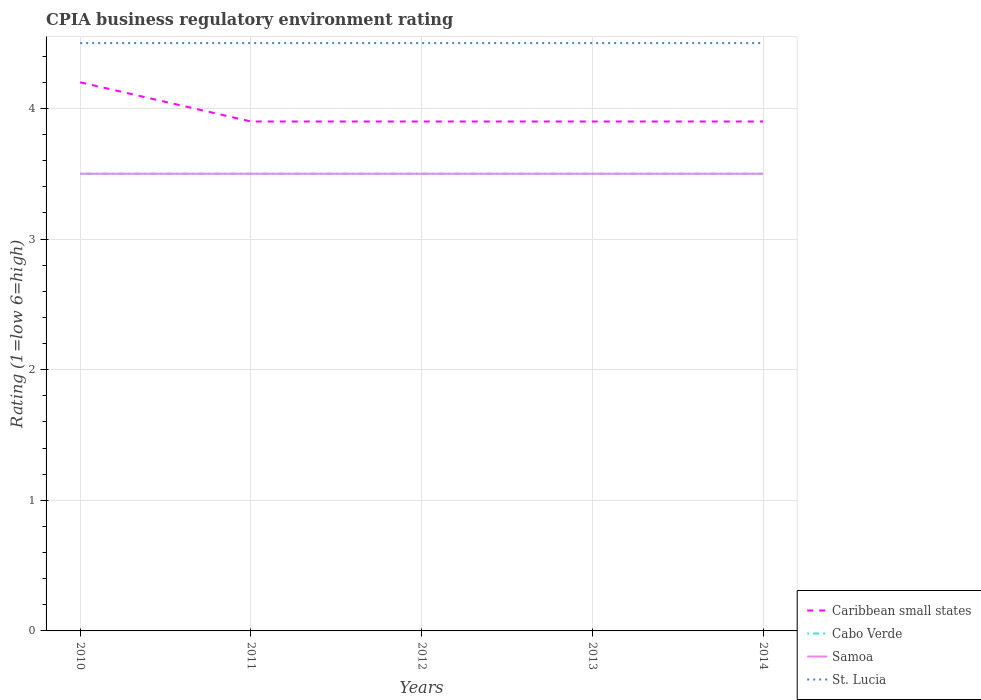How many different coloured lines are there?
Give a very brief answer. 4. Does the line corresponding to Samoa intersect with the line corresponding to Caribbean small states?
Your answer should be compact. No. Is the number of lines equal to the number of legend labels?
Offer a terse response. Yes. Across all years, what is the maximum CPIA rating in Cabo Verde?
Ensure brevity in your answer.  3.5. In which year was the CPIA rating in St. Lucia maximum?
Give a very brief answer. 2010. What is the total CPIA rating in Cabo Verde in the graph?
Provide a short and direct response. 0. What is the difference between the highest and the lowest CPIA rating in Caribbean small states?
Give a very brief answer. 1. How many lines are there?
Keep it short and to the point. 4. How many years are there in the graph?
Keep it short and to the point. 5. What is the difference between two consecutive major ticks on the Y-axis?
Offer a very short reply. 1. Are the values on the major ticks of Y-axis written in scientific E-notation?
Offer a terse response. No. Where does the legend appear in the graph?
Make the answer very short. Bottom right. What is the title of the graph?
Offer a terse response. CPIA business regulatory environment rating. Does "Least developed countries" appear as one of the legend labels in the graph?
Your answer should be very brief. No. What is the label or title of the X-axis?
Offer a terse response. Years. What is the label or title of the Y-axis?
Give a very brief answer. Rating (1=low 6=high). What is the Rating (1=low 6=high) of Samoa in 2010?
Your answer should be compact. 3.5. What is the Rating (1=low 6=high) in St. Lucia in 2010?
Ensure brevity in your answer.  4.5. What is the Rating (1=low 6=high) in Samoa in 2011?
Your answer should be compact. 3.5. What is the Rating (1=low 6=high) in Caribbean small states in 2012?
Provide a short and direct response. 3.9. What is the Rating (1=low 6=high) in Samoa in 2012?
Give a very brief answer. 3.5. What is the Rating (1=low 6=high) in St. Lucia in 2012?
Your answer should be compact. 4.5. What is the Rating (1=low 6=high) in Caribbean small states in 2013?
Provide a short and direct response. 3.9. What is the Rating (1=low 6=high) of Cabo Verde in 2013?
Ensure brevity in your answer.  3.5. What is the Rating (1=low 6=high) in St. Lucia in 2013?
Keep it short and to the point. 4.5. What is the Rating (1=low 6=high) of Samoa in 2014?
Your answer should be very brief. 3.5. Across all years, what is the maximum Rating (1=low 6=high) in Caribbean small states?
Offer a terse response. 4.2. Across all years, what is the maximum Rating (1=low 6=high) of Cabo Verde?
Your response must be concise. 3.5. Across all years, what is the maximum Rating (1=low 6=high) in St. Lucia?
Make the answer very short. 4.5. Across all years, what is the minimum Rating (1=low 6=high) in Caribbean small states?
Your answer should be very brief. 3.9. What is the total Rating (1=low 6=high) in Caribbean small states in the graph?
Your response must be concise. 19.8. What is the total Rating (1=low 6=high) in Samoa in the graph?
Ensure brevity in your answer.  17.5. What is the total Rating (1=low 6=high) of St. Lucia in the graph?
Offer a very short reply. 22.5. What is the difference between the Rating (1=low 6=high) of Samoa in 2010 and that in 2011?
Give a very brief answer. 0. What is the difference between the Rating (1=low 6=high) of Caribbean small states in 2010 and that in 2012?
Your answer should be very brief. 0.3. What is the difference between the Rating (1=low 6=high) of Caribbean small states in 2010 and that in 2013?
Keep it short and to the point. 0.3. What is the difference between the Rating (1=low 6=high) of Cabo Verde in 2010 and that in 2013?
Provide a short and direct response. 0. What is the difference between the Rating (1=low 6=high) of Samoa in 2010 and that in 2013?
Your answer should be very brief. 0. What is the difference between the Rating (1=low 6=high) of Caribbean small states in 2010 and that in 2014?
Offer a terse response. 0.3. What is the difference between the Rating (1=low 6=high) of St. Lucia in 2010 and that in 2014?
Keep it short and to the point. 0. What is the difference between the Rating (1=low 6=high) in Cabo Verde in 2011 and that in 2012?
Give a very brief answer. 0. What is the difference between the Rating (1=low 6=high) of St. Lucia in 2011 and that in 2012?
Keep it short and to the point. 0. What is the difference between the Rating (1=low 6=high) of St. Lucia in 2011 and that in 2013?
Your answer should be very brief. 0. What is the difference between the Rating (1=low 6=high) of Caribbean small states in 2011 and that in 2014?
Offer a very short reply. 0. What is the difference between the Rating (1=low 6=high) of Samoa in 2011 and that in 2014?
Keep it short and to the point. 0. What is the difference between the Rating (1=low 6=high) of St. Lucia in 2011 and that in 2014?
Keep it short and to the point. 0. What is the difference between the Rating (1=low 6=high) in Samoa in 2012 and that in 2013?
Give a very brief answer. 0. What is the difference between the Rating (1=low 6=high) in Samoa in 2012 and that in 2014?
Give a very brief answer. 0. What is the difference between the Rating (1=low 6=high) in St. Lucia in 2012 and that in 2014?
Give a very brief answer. 0. What is the difference between the Rating (1=low 6=high) of Cabo Verde in 2013 and that in 2014?
Your response must be concise. 0. What is the difference between the Rating (1=low 6=high) of Samoa in 2013 and that in 2014?
Your answer should be compact. 0. What is the difference between the Rating (1=low 6=high) of St. Lucia in 2013 and that in 2014?
Provide a short and direct response. 0. What is the difference between the Rating (1=low 6=high) of Caribbean small states in 2010 and the Rating (1=low 6=high) of Cabo Verde in 2011?
Keep it short and to the point. 0.7. What is the difference between the Rating (1=low 6=high) of Cabo Verde in 2010 and the Rating (1=low 6=high) of Samoa in 2011?
Keep it short and to the point. 0. What is the difference between the Rating (1=low 6=high) of Cabo Verde in 2010 and the Rating (1=low 6=high) of St. Lucia in 2011?
Offer a very short reply. -1. What is the difference between the Rating (1=low 6=high) of Samoa in 2010 and the Rating (1=low 6=high) of St. Lucia in 2011?
Offer a terse response. -1. What is the difference between the Rating (1=low 6=high) in Caribbean small states in 2010 and the Rating (1=low 6=high) in St. Lucia in 2012?
Give a very brief answer. -0.3. What is the difference between the Rating (1=low 6=high) in Cabo Verde in 2010 and the Rating (1=low 6=high) in Samoa in 2012?
Provide a succinct answer. 0. What is the difference between the Rating (1=low 6=high) in Samoa in 2010 and the Rating (1=low 6=high) in St. Lucia in 2012?
Provide a succinct answer. -1. What is the difference between the Rating (1=low 6=high) in Caribbean small states in 2010 and the Rating (1=low 6=high) in Cabo Verde in 2013?
Offer a terse response. 0.7. What is the difference between the Rating (1=low 6=high) in Caribbean small states in 2010 and the Rating (1=low 6=high) in Samoa in 2013?
Make the answer very short. 0.7. What is the difference between the Rating (1=low 6=high) of Cabo Verde in 2010 and the Rating (1=low 6=high) of Samoa in 2013?
Offer a very short reply. 0. What is the difference between the Rating (1=low 6=high) of Cabo Verde in 2010 and the Rating (1=low 6=high) of St. Lucia in 2013?
Your answer should be very brief. -1. What is the difference between the Rating (1=low 6=high) in Samoa in 2010 and the Rating (1=low 6=high) in St. Lucia in 2013?
Your response must be concise. -1. What is the difference between the Rating (1=low 6=high) of Caribbean small states in 2010 and the Rating (1=low 6=high) of Cabo Verde in 2014?
Provide a succinct answer. 0.7. What is the difference between the Rating (1=low 6=high) in Cabo Verde in 2010 and the Rating (1=low 6=high) in Samoa in 2014?
Your answer should be very brief. 0. What is the difference between the Rating (1=low 6=high) in Caribbean small states in 2011 and the Rating (1=low 6=high) in Cabo Verde in 2012?
Ensure brevity in your answer.  0.4. What is the difference between the Rating (1=low 6=high) of Caribbean small states in 2011 and the Rating (1=low 6=high) of St. Lucia in 2012?
Your answer should be very brief. -0.6. What is the difference between the Rating (1=low 6=high) of Samoa in 2011 and the Rating (1=low 6=high) of St. Lucia in 2012?
Offer a terse response. -1. What is the difference between the Rating (1=low 6=high) of Caribbean small states in 2011 and the Rating (1=low 6=high) of Cabo Verde in 2013?
Give a very brief answer. 0.4. What is the difference between the Rating (1=low 6=high) of Caribbean small states in 2011 and the Rating (1=low 6=high) of Samoa in 2013?
Offer a terse response. 0.4. What is the difference between the Rating (1=low 6=high) in Caribbean small states in 2011 and the Rating (1=low 6=high) in Cabo Verde in 2014?
Give a very brief answer. 0.4. What is the difference between the Rating (1=low 6=high) of Caribbean small states in 2011 and the Rating (1=low 6=high) of Samoa in 2014?
Provide a succinct answer. 0.4. What is the difference between the Rating (1=low 6=high) of Cabo Verde in 2011 and the Rating (1=low 6=high) of Samoa in 2014?
Give a very brief answer. 0. What is the difference between the Rating (1=low 6=high) in Cabo Verde in 2011 and the Rating (1=low 6=high) in St. Lucia in 2014?
Your answer should be very brief. -1. What is the difference between the Rating (1=low 6=high) in Caribbean small states in 2012 and the Rating (1=low 6=high) in Samoa in 2013?
Provide a succinct answer. 0.4. What is the difference between the Rating (1=low 6=high) of Caribbean small states in 2012 and the Rating (1=low 6=high) of St. Lucia in 2013?
Your answer should be compact. -0.6. What is the difference between the Rating (1=low 6=high) in Samoa in 2012 and the Rating (1=low 6=high) in St. Lucia in 2013?
Provide a short and direct response. -1. What is the difference between the Rating (1=low 6=high) in Cabo Verde in 2012 and the Rating (1=low 6=high) in Samoa in 2014?
Ensure brevity in your answer.  0. What is the difference between the Rating (1=low 6=high) in Samoa in 2012 and the Rating (1=low 6=high) in St. Lucia in 2014?
Offer a terse response. -1. What is the difference between the Rating (1=low 6=high) of Caribbean small states in 2013 and the Rating (1=low 6=high) of Cabo Verde in 2014?
Your response must be concise. 0.4. What is the difference between the Rating (1=low 6=high) of Caribbean small states in 2013 and the Rating (1=low 6=high) of St. Lucia in 2014?
Keep it short and to the point. -0.6. What is the difference between the Rating (1=low 6=high) in Cabo Verde in 2013 and the Rating (1=low 6=high) in St. Lucia in 2014?
Provide a short and direct response. -1. What is the difference between the Rating (1=low 6=high) in Samoa in 2013 and the Rating (1=low 6=high) in St. Lucia in 2014?
Your response must be concise. -1. What is the average Rating (1=low 6=high) of Caribbean small states per year?
Your answer should be compact. 3.96. What is the average Rating (1=low 6=high) in Cabo Verde per year?
Give a very brief answer. 3.5. What is the average Rating (1=low 6=high) of Samoa per year?
Offer a terse response. 3.5. What is the average Rating (1=low 6=high) of St. Lucia per year?
Provide a short and direct response. 4.5. In the year 2010, what is the difference between the Rating (1=low 6=high) in Samoa and Rating (1=low 6=high) in St. Lucia?
Ensure brevity in your answer.  -1. In the year 2011, what is the difference between the Rating (1=low 6=high) in Caribbean small states and Rating (1=low 6=high) in St. Lucia?
Make the answer very short. -0.6. In the year 2011, what is the difference between the Rating (1=low 6=high) in Cabo Verde and Rating (1=low 6=high) in St. Lucia?
Your answer should be compact. -1. In the year 2011, what is the difference between the Rating (1=low 6=high) in Samoa and Rating (1=low 6=high) in St. Lucia?
Your response must be concise. -1. In the year 2012, what is the difference between the Rating (1=low 6=high) of Cabo Verde and Rating (1=low 6=high) of St. Lucia?
Your answer should be very brief. -1. In the year 2012, what is the difference between the Rating (1=low 6=high) in Samoa and Rating (1=low 6=high) in St. Lucia?
Your response must be concise. -1. In the year 2013, what is the difference between the Rating (1=low 6=high) in Caribbean small states and Rating (1=low 6=high) in Cabo Verde?
Give a very brief answer. 0.4. In the year 2013, what is the difference between the Rating (1=low 6=high) of Caribbean small states and Rating (1=low 6=high) of St. Lucia?
Provide a short and direct response. -0.6. In the year 2014, what is the difference between the Rating (1=low 6=high) in Caribbean small states and Rating (1=low 6=high) in Cabo Verde?
Your response must be concise. 0.4. In the year 2014, what is the difference between the Rating (1=low 6=high) of Caribbean small states and Rating (1=low 6=high) of Samoa?
Keep it short and to the point. 0.4. In the year 2014, what is the difference between the Rating (1=low 6=high) of Caribbean small states and Rating (1=low 6=high) of St. Lucia?
Ensure brevity in your answer.  -0.6. In the year 2014, what is the difference between the Rating (1=low 6=high) in Cabo Verde and Rating (1=low 6=high) in St. Lucia?
Offer a very short reply. -1. In the year 2014, what is the difference between the Rating (1=low 6=high) in Samoa and Rating (1=low 6=high) in St. Lucia?
Your answer should be very brief. -1. What is the ratio of the Rating (1=low 6=high) in Cabo Verde in 2010 to that in 2011?
Provide a short and direct response. 1. What is the ratio of the Rating (1=low 6=high) of Samoa in 2010 to that in 2011?
Provide a short and direct response. 1. What is the ratio of the Rating (1=low 6=high) in Samoa in 2010 to that in 2012?
Offer a very short reply. 1. What is the ratio of the Rating (1=low 6=high) in St. Lucia in 2010 to that in 2012?
Ensure brevity in your answer.  1. What is the ratio of the Rating (1=low 6=high) in Cabo Verde in 2010 to that in 2013?
Your answer should be compact. 1. What is the ratio of the Rating (1=low 6=high) of Samoa in 2010 to that in 2013?
Give a very brief answer. 1. What is the ratio of the Rating (1=low 6=high) in St. Lucia in 2010 to that in 2013?
Give a very brief answer. 1. What is the ratio of the Rating (1=low 6=high) of Caribbean small states in 2010 to that in 2014?
Offer a very short reply. 1.08. What is the ratio of the Rating (1=low 6=high) of Cabo Verde in 2010 to that in 2014?
Ensure brevity in your answer.  1. What is the ratio of the Rating (1=low 6=high) of Caribbean small states in 2011 to that in 2012?
Ensure brevity in your answer.  1. What is the ratio of the Rating (1=low 6=high) in Samoa in 2011 to that in 2012?
Ensure brevity in your answer.  1. What is the ratio of the Rating (1=low 6=high) in Caribbean small states in 2011 to that in 2013?
Your response must be concise. 1. What is the ratio of the Rating (1=low 6=high) of Caribbean small states in 2011 to that in 2014?
Offer a terse response. 1. What is the ratio of the Rating (1=low 6=high) in Cabo Verde in 2011 to that in 2014?
Ensure brevity in your answer.  1. What is the ratio of the Rating (1=low 6=high) in St. Lucia in 2011 to that in 2014?
Ensure brevity in your answer.  1. What is the ratio of the Rating (1=low 6=high) of Caribbean small states in 2012 to that in 2013?
Offer a very short reply. 1. What is the ratio of the Rating (1=low 6=high) of Samoa in 2012 to that in 2013?
Ensure brevity in your answer.  1. What is the ratio of the Rating (1=low 6=high) in Caribbean small states in 2012 to that in 2014?
Offer a very short reply. 1. What is the ratio of the Rating (1=low 6=high) of Cabo Verde in 2012 to that in 2014?
Provide a succinct answer. 1. What is the ratio of the Rating (1=low 6=high) of Samoa in 2013 to that in 2014?
Your response must be concise. 1. What is the difference between the highest and the second highest Rating (1=low 6=high) of Cabo Verde?
Provide a short and direct response. 0. What is the difference between the highest and the second highest Rating (1=low 6=high) of St. Lucia?
Your answer should be compact. 0. What is the difference between the highest and the lowest Rating (1=low 6=high) in Caribbean small states?
Your answer should be very brief. 0.3. What is the difference between the highest and the lowest Rating (1=low 6=high) of Samoa?
Provide a short and direct response. 0. What is the difference between the highest and the lowest Rating (1=low 6=high) in St. Lucia?
Offer a terse response. 0. 